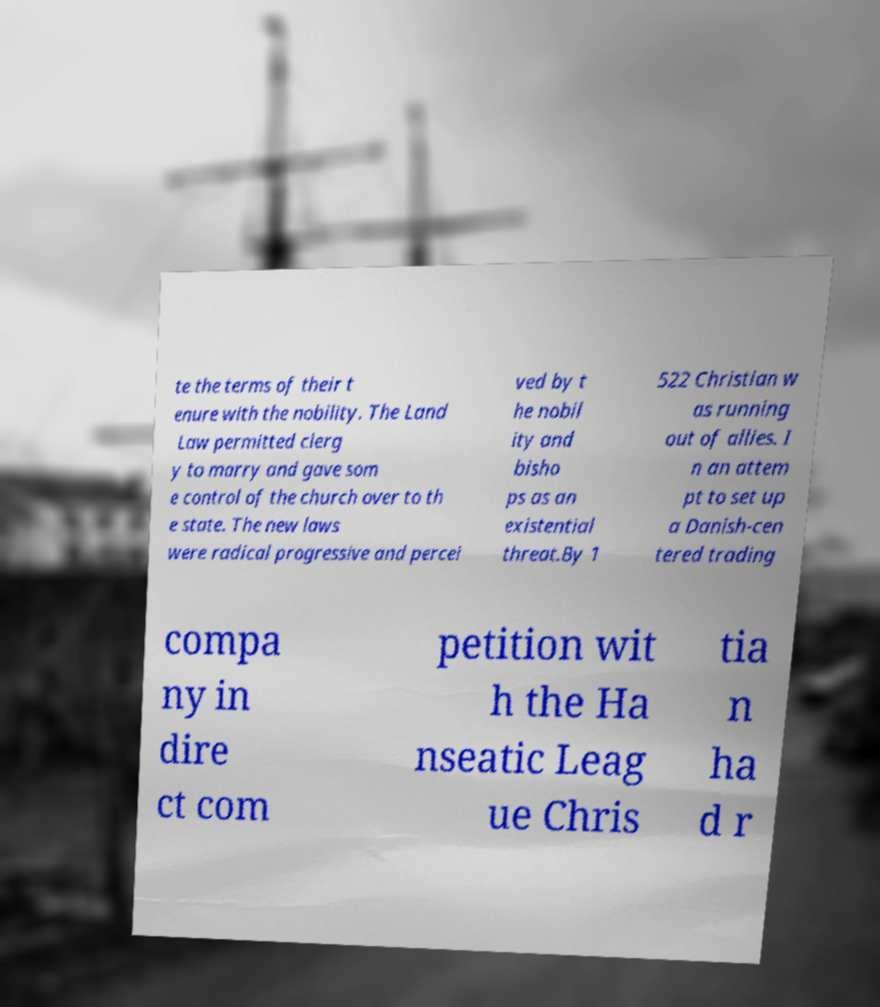Please identify and transcribe the text found in this image. te the terms of their t enure with the nobility. The Land Law permitted clerg y to marry and gave som e control of the church over to th e state. The new laws were radical progressive and percei ved by t he nobil ity and bisho ps as an existential threat.By 1 522 Christian w as running out of allies. I n an attem pt to set up a Danish-cen tered trading compa ny in dire ct com petition wit h the Ha nseatic Leag ue Chris tia n ha d r 